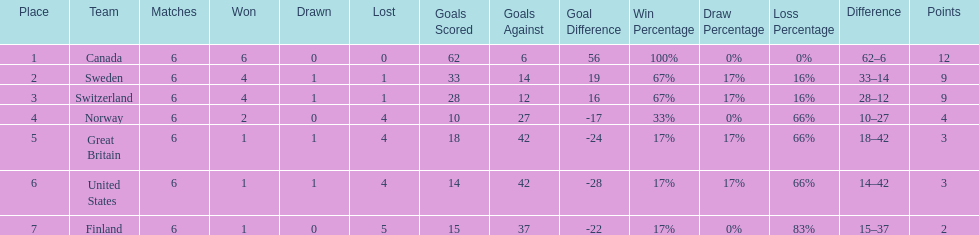How many points did great britain secure in the competition? 3. 